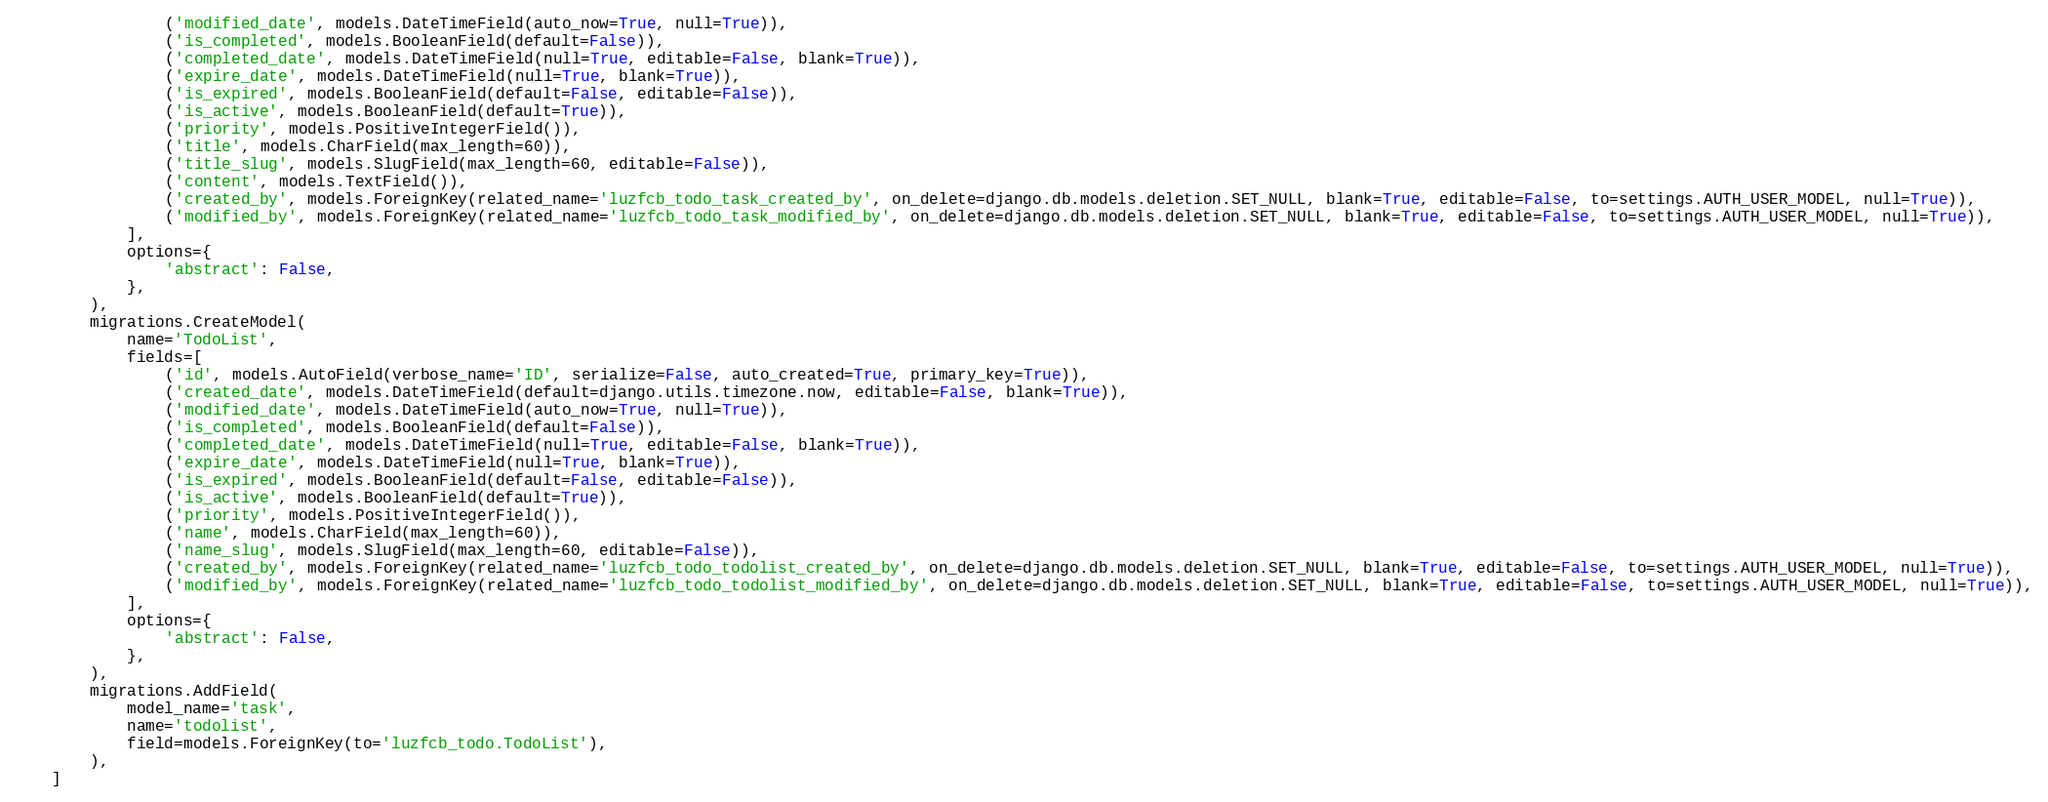Convert code to text. <code><loc_0><loc_0><loc_500><loc_500><_Python_>                ('modified_date', models.DateTimeField(auto_now=True, null=True)),
                ('is_completed', models.BooleanField(default=False)),
                ('completed_date', models.DateTimeField(null=True, editable=False, blank=True)),
                ('expire_date', models.DateTimeField(null=True, blank=True)),
                ('is_expired', models.BooleanField(default=False, editable=False)),
                ('is_active', models.BooleanField(default=True)),
                ('priority', models.PositiveIntegerField()),
                ('title', models.CharField(max_length=60)),
                ('title_slug', models.SlugField(max_length=60, editable=False)),
                ('content', models.TextField()),
                ('created_by', models.ForeignKey(related_name='luzfcb_todo_task_created_by', on_delete=django.db.models.deletion.SET_NULL, blank=True, editable=False, to=settings.AUTH_USER_MODEL, null=True)),
                ('modified_by', models.ForeignKey(related_name='luzfcb_todo_task_modified_by', on_delete=django.db.models.deletion.SET_NULL, blank=True, editable=False, to=settings.AUTH_USER_MODEL, null=True)),
            ],
            options={
                'abstract': False,
            },
        ),
        migrations.CreateModel(
            name='TodoList',
            fields=[
                ('id', models.AutoField(verbose_name='ID', serialize=False, auto_created=True, primary_key=True)),
                ('created_date', models.DateTimeField(default=django.utils.timezone.now, editable=False, blank=True)),
                ('modified_date', models.DateTimeField(auto_now=True, null=True)),
                ('is_completed', models.BooleanField(default=False)),
                ('completed_date', models.DateTimeField(null=True, editable=False, blank=True)),
                ('expire_date', models.DateTimeField(null=True, blank=True)),
                ('is_expired', models.BooleanField(default=False, editable=False)),
                ('is_active', models.BooleanField(default=True)),
                ('priority', models.PositiveIntegerField()),
                ('name', models.CharField(max_length=60)),
                ('name_slug', models.SlugField(max_length=60, editable=False)),
                ('created_by', models.ForeignKey(related_name='luzfcb_todo_todolist_created_by', on_delete=django.db.models.deletion.SET_NULL, blank=True, editable=False, to=settings.AUTH_USER_MODEL, null=True)),
                ('modified_by', models.ForeignKey(related_name='luzfcb_todo_todolist_modified_by', on_delete=django.db.models.deletion.SET_NULL, blank=True, editable=False, to=settings.AUTH_USER_MODEL, null=True)),
            ],
            options={
                'abstract': False,
            },
        ),
        migrations.AddField(
            model_name='task',
            name='todolist',
            field=models.ForeignKey(to='luzfcb_todo.TodoList'),
        ),
    ]
</code> 